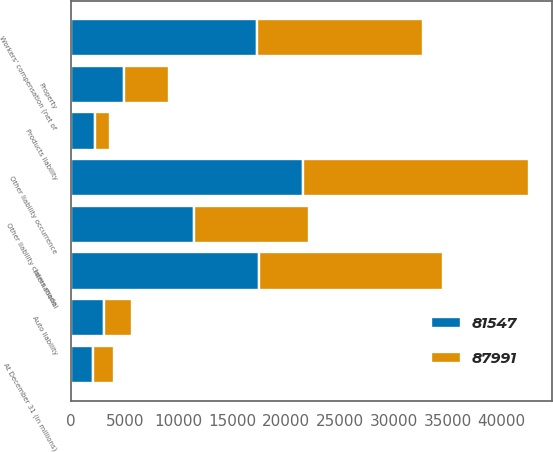Convert chart to OTSL. <chart><loc_0><loc_0><loc_500><loc_500><stacked_bar_chart><ecel><fcel>At December 31 (in millions)<fcel>Other liability occurrence<fcel>International<fcel>Workers' compensation (net of<fcel>Other liability claims made<fcel>Property<fcel>Auto liability<fcel>Products liability<nl><fcel>87991<fcel>2013<fcel>21023<fcel>17126<fcel>15390<fcel>10645<fcel>4111<fcel>2581<fcel>1463<nl><fcel>81547<fcel>2012<fcel>21533<fcel>17453<fcel>17319<fcel>11443<fcel>4961<fcel>3060<fcel>2195<nl></chart> 